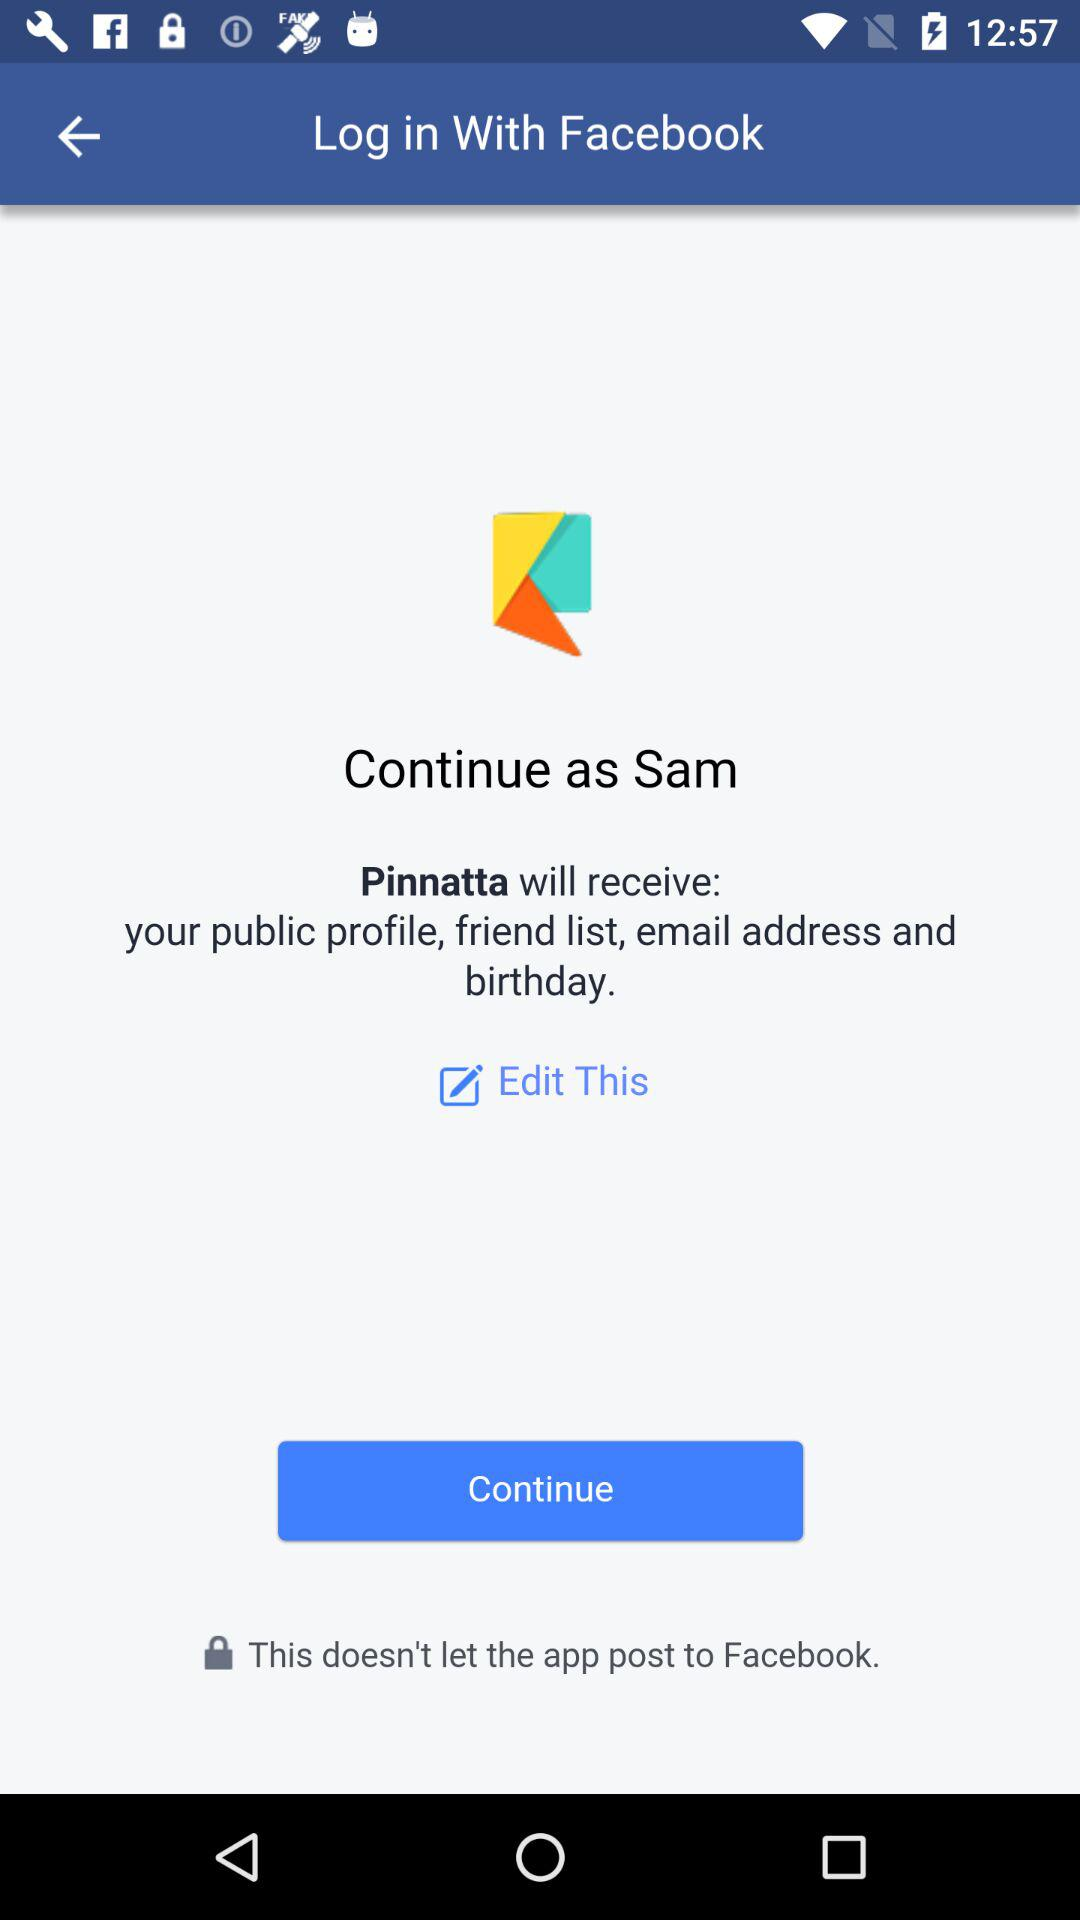What application is asking for permission? The application asking for permission is "Pinnatta". 